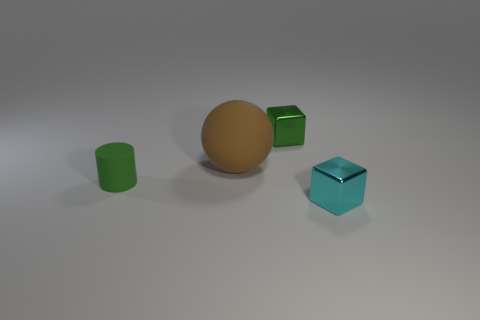Add 1 cylinders. How many objects exist? 5 Subtract all spheres. How many objects are left? 3 Add 1 cyan things. How many cyan things are left? 2 Add 3 green cylinders. How many green cylinders exist? 4 Subtract 0 blue spheres. How many objects are left? 4 Subtract all purple shiny objects. Subtract all green metallic cubes. How many objects are left? 3 